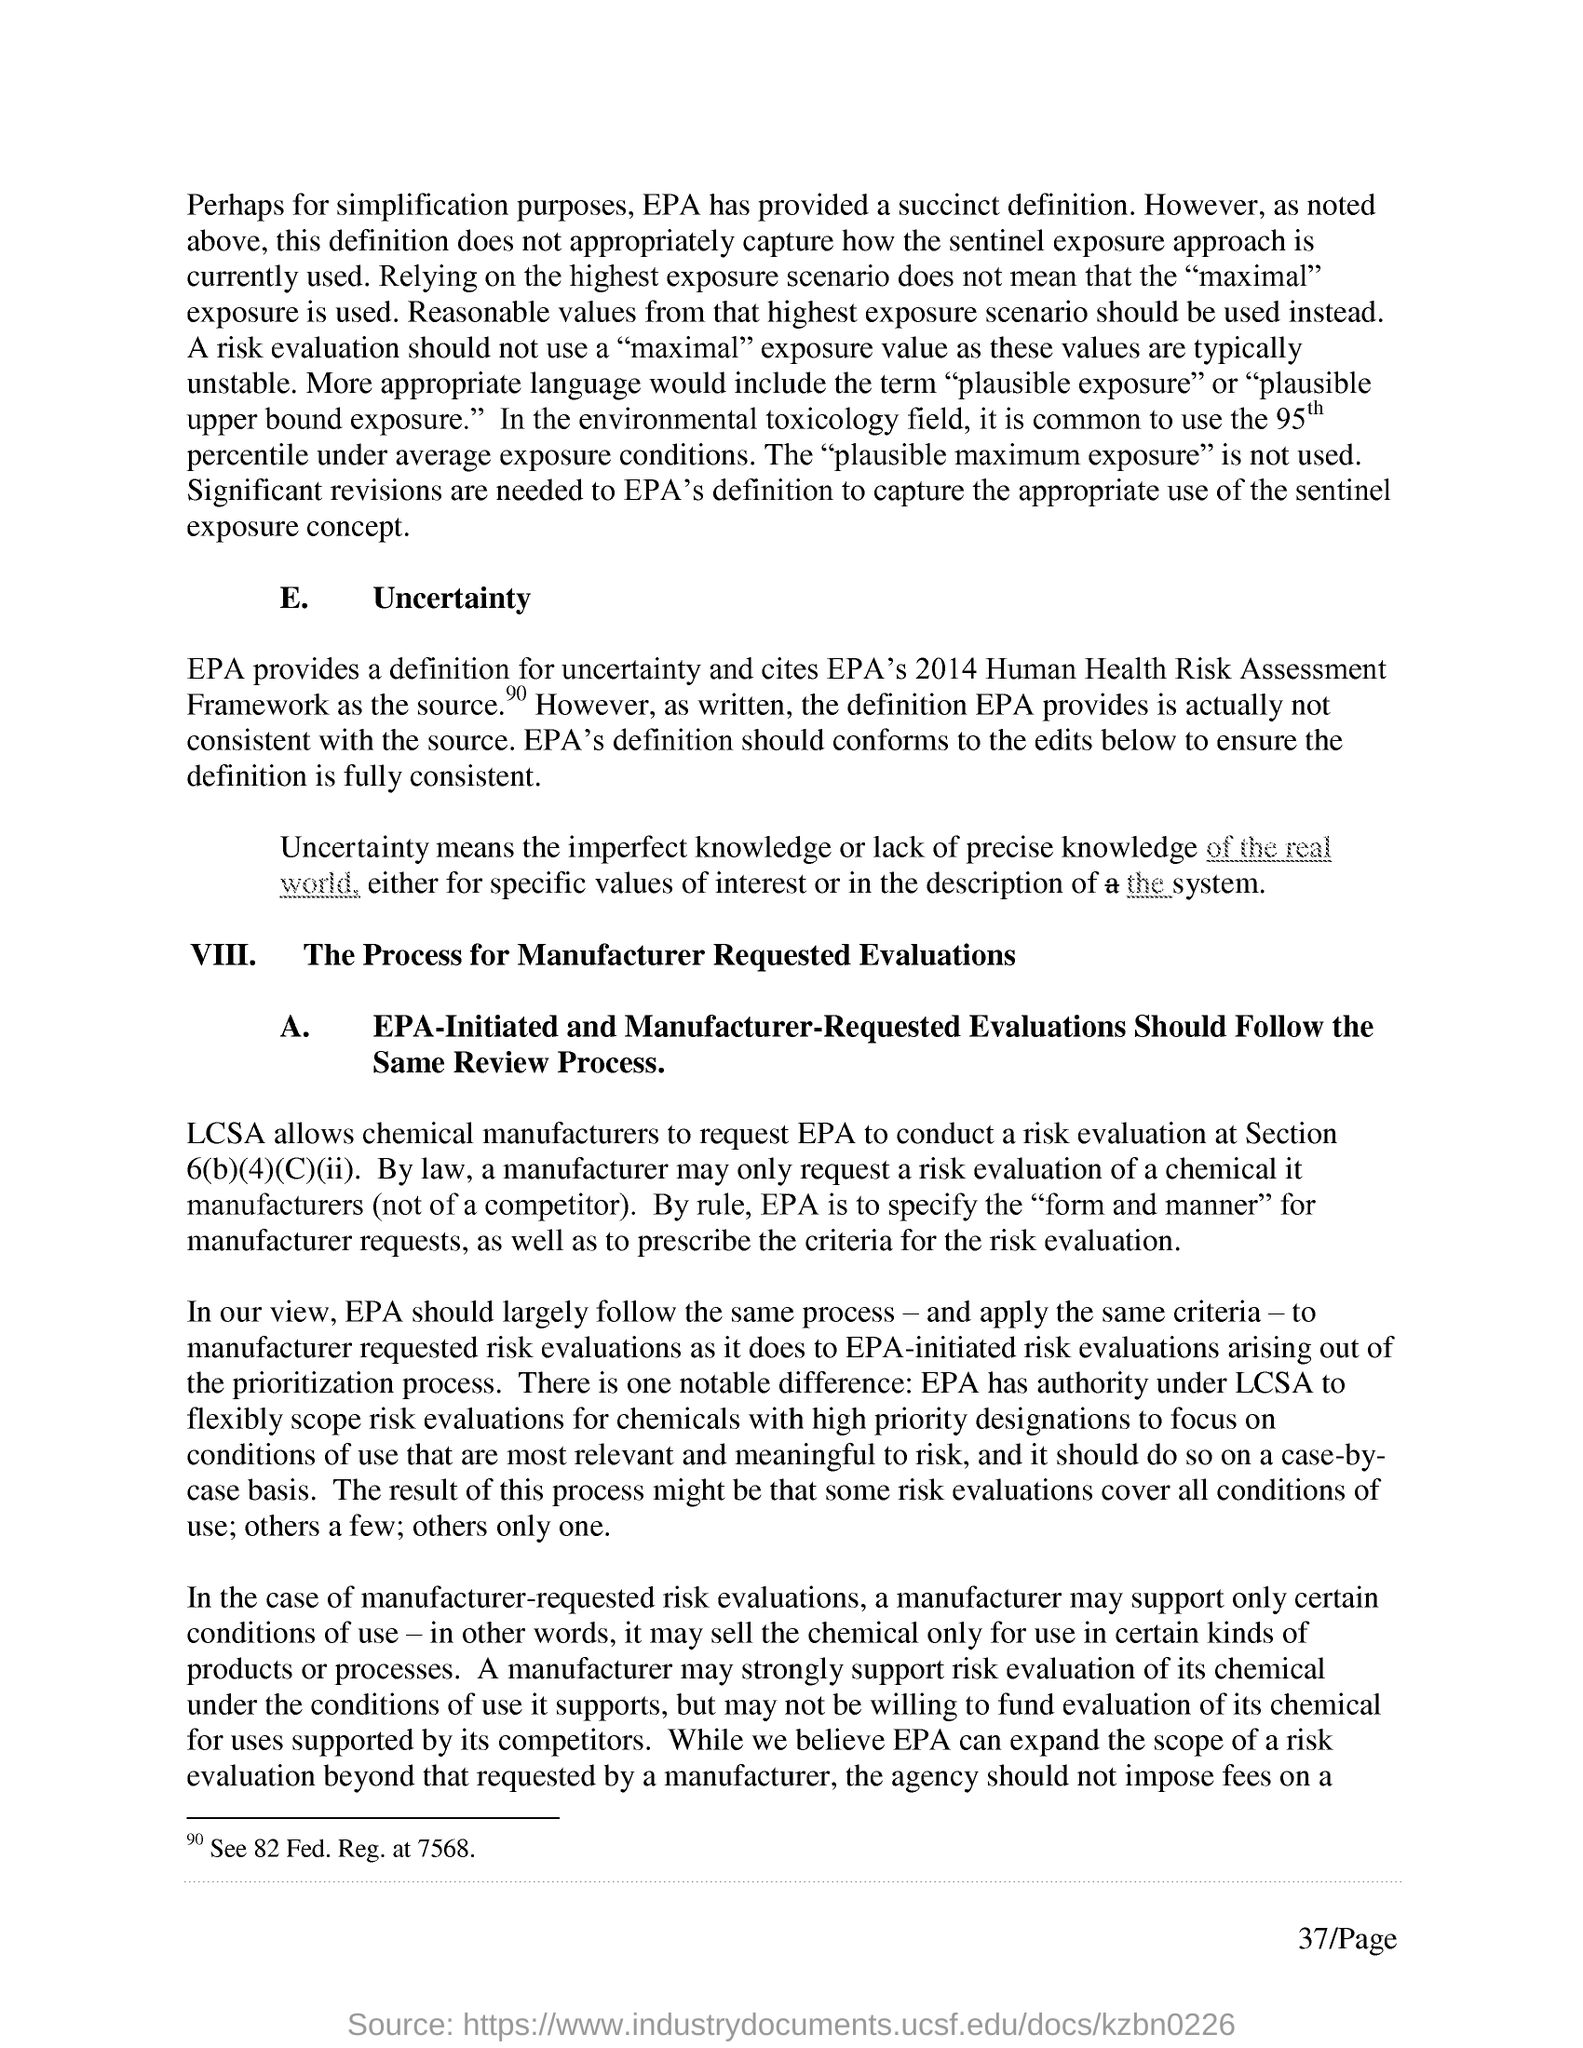What is commonly used in the environmental toxicology field?
Keep it short and to the point. 95th percentile under average exposure conditions. Which field does not use the "plausible maximum exposure" ?
Your response must be concise. Environmental toxicology field. What does EPA cites as the source?
Provide a short and direct response. Cites epa's 2014 human health risk assessment framework as the source. 